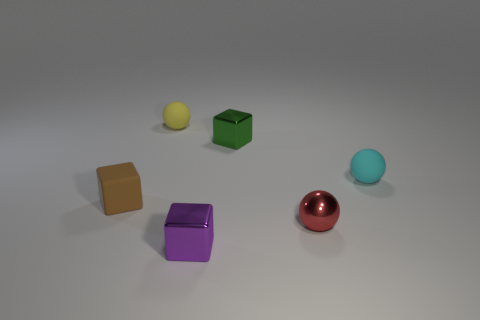Add 2 green metal things. How many objects exist? 8 Subtract 1 cyan balls. How many objects are left? 5 Subtract all brown rubber cubes. Subtract all green metal things. How many objects are left? 4 Add 3 small green shiny things. How many small green shiny things are left? 4 Add 3 tiny green metal blocks. How many tiny green metal blocks exist? 4 